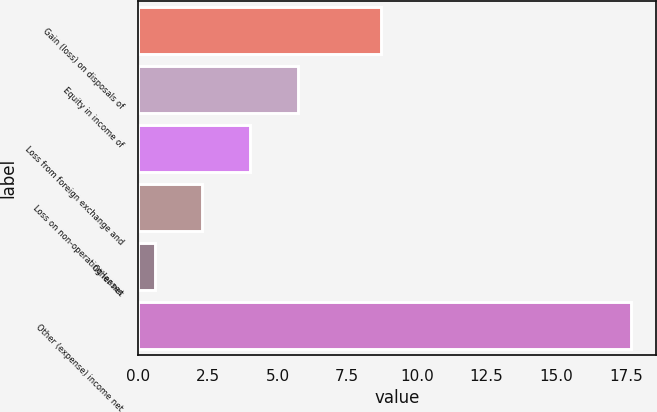Convert chart to OTSL. <chart><loc_0><loc_0><loc_500><loc_500><bar_chart><fcel>Gain (loss) on disposals of<fcel>Equity in income of<fcel>Loss from foreign exchange and<fcel>Loss on non-operating leases<fcel>Other net<fcel>Other (expense) income net<nl><fcel>8.7<fcel>5.73<fcel>4.02<fcel>2.31<fcel>0.6<fcel>17.7<nl></chart> 